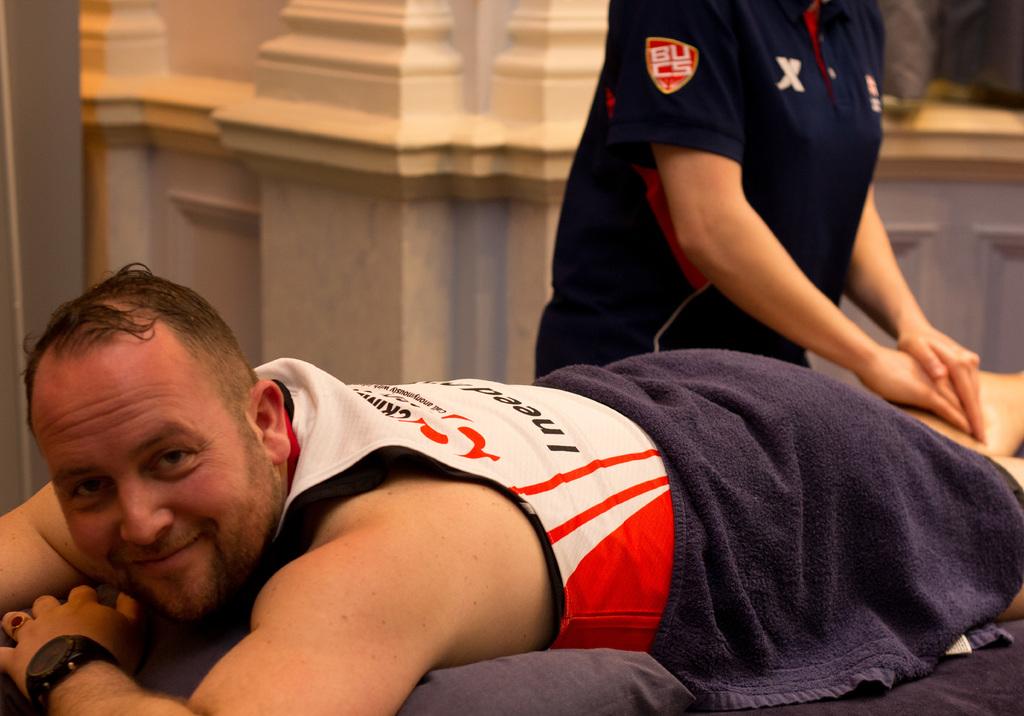What's color of the text on the dark t-shirt sleeve?
Give a very brief answer. Answering does not require reading text in the image. What's is the letters on the patch on the blue sleeve?
Your response must be concise. Bucs. 